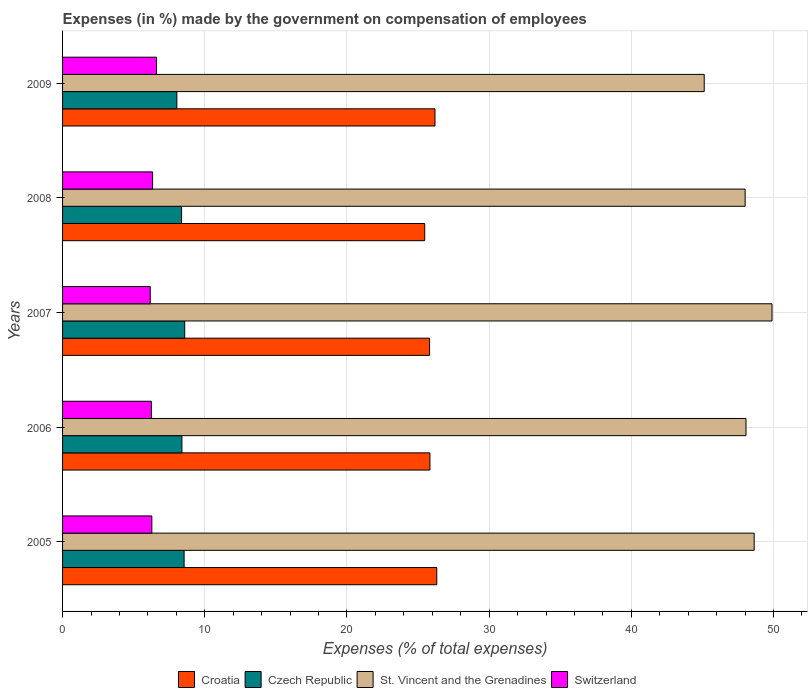How many different coloured bars are there?
Give a very brief answer. 4. Are the number of bars on each tick of the Y-axis equal?
Your answer should be compact. Yes. How many bars are there on the 2nd tick from the top?
Your answer should be very brief. 4. In how many cases, is the number of bars for a given year not equal to the number of legend labels?
Provide a succinct answer. 0. What is the percentage of expenses made by the government on compensation of employees in Croatia in 2006?
Your answer should be very brief. 25.84. Across all years, what is the maximum percentage of expenses made by the government on compensation of employees in Switzerland?
Make the answer very short. 6.61. Across all years, what is the minimum percentage of expenses made by the government on compensation of employees in Switzerland?
Your answer should be very brief. 6.17. In which year was the percentage of expenses made by the government on compensation of employees in Switzerland minimum?
Keep it short and to the point. 2007. What is the total percentage of expenses made by the government on compensation of employees in Switzerland in the graph?
Ensure brevity in your answer.  31.63. What is the difference between the percentage of expenses made by the government on compensation of employees in St. Vincent and the Grenadines in 2006 and that in 2009?
Provide a short and direct response. 2.94. What is the difference between the percentage of expenses made by the government on compensation of employees in Croatia in 2009 and the percentage of expenses made by the government on compensation of employees in Czech Republic in 2008?
Offer a very short reply. 17.82. What is the average percentage of expenses made by the government on compensation of employees in Croatia per year?
Offer a very short reply. 25.93. In the year 2006, what is the difference between the percentage of expenses made by the government on compensation of employees in Switzerland and percentage of expenses made by the government on compensation of employees in St. Vincent and the Grenadines?
Your answer should be compact. -41.82. In how many years, is the percentage of expenses made by the government on compensation of employees in Croatia greater than 22 %?
Make the answer very short. 5. What is the ratio of the percentage of expenses made by the government on compensation of employees in Czech Republic in 2006 to that in 2007?
Provide a short and direct response. 0.98. Is the percentage of expenses made by the government on compensation of employees in Switzerland in 2005 less than that in 2006?
Offer a very short reply. No. What is the difference between the highest and the second highest percentage of expenses made by the government on compensation of employees in Switzerland?
Keep it short and to the point. 0.28. What is the difference between the highest and the lowest percentage of expenses made by the government on compensation of employees in Croatia?
Ensure brevity in your answer.  0.85. Is the sum of the percentage of expenses made by the government on compensation of employees in St. Vincent and the Grenadines in 2008 and 2009 greater than the maximum percentage of expenses made by the government on compensation of employees in Czech Republic across all years?
Ensure brevity in your answer.  Yes. Is it the case that in every year, the sum of the percentage of expenses made by the government on compensation of employees in Czech Republic and percentage of expenses made by the government on compensation of employees in Switzerland is greater than the sum of percentage of expenses made by the government on compensation of employees in Croatia and percentage of expenses made by the government on compensation of employees in St. Vincent and the Grenadines?
Give a very brief answer. No. What does the 3rd bar from the top in 2007 represents?
Provide a short and direct response. Czech Republic. What does the 3rd bar from the bottom in 2009 represents?
Provide a succinct answer. St. Vincent and the Grenadines. How many bars are there?
Provide a succinct answer. 20. Are all the bars in the graph horizontal?
Your answer should be very brief. Yes. What is the difference between two consecutive major ticks on the X-axis?
Give a very brief answer. 10. Are the values on the major ticks of X-axis written in scientific E-notation?
Your answer should be very brief. No. Does the graph contain grids?
Ensure brevity in your answer.  Yes. Where does the legend appear in the graph?
Make the answer very short. Bottom center. How many legend labels are there?
Your answer should be compact. 4. What is the title of the graph?
Ensure brevity in your answer.  Expenses (in %) made by the government on compensation of employees. Does "Rwanda" appear as one of the legend labels in the graph?
Give a very brief answer. No. What is the label or title of the X-axis?
Offer a terse response. Expenses (% of total expenses). What is the Expenses (% of total expenses) in Croatia in 2005?
Your answer should be compact. 26.32. What is the Expenses (% of total expenses) of Czech Republic in 2005?
Ensure brevity in your answer.  8.55. What is the Expenses (% of total expenses) of St. Vincent and the Grenadines in 2005?
Provide a succinct answer. 48.64. What is the Expenses (% of total expenses) in Switzerland in 2005?
Ensure brevity in your answer.  6.28. What is the Expenses (% of total expenses) of Croatia in 2006?
Your answer should be very brief. 25.84. What is the Expenses (% of total expenses) in Czech Republic in 2006?
Offer a terse response. 8.39. What is the Expenses (% of total expenses) in St. Vincent and the Grenadines in 2006?
Give a very brief answer. 48.06. What is the Expenses (% of total expenses) of Switzerland in 2006?
Ensure brevity in your answer.  6.24. What is the Expenses (% of total expenses) of Croatia in 2007?
Give a very brief answer. 25.81. What is the Expenses (% of total expenses) in Czech Republic in 2007?
Provide a succinct answer. 8.59. What is the Expenses (% of total expenses) of St. Vincent and the Grenadines in 2007?
Provide a short and direct response. 49.89. What is the Expenses (% of total expenses) in Switzerland in 2007?
Your answer should be compact. 6.17. What is the Expenses (% of total expenses) of Croatia in 2008?
Offer a very short reply. 25.47. What is the Expenses (% of total expenses) in Czech Republic in 2008?
Give a very brief answer. 8.37. What is the Expenses (% of total expenses) of St. Vincent and the Grenadines in 2008?
Keep it short and to the point. 48. What is the Expenses (% of total expenses) in Switzerland in 2008?
Make the answer very short. 6.33. What is the Expenses (% of total expenses) in Croatia in 2009?
Give a very brief answer. 26.19. What is the Expenses (% of total expenses) of Czech Republic in 2009?
Offer a terse response. 8.04. What is the Expenses (% of total expenses) in St. Vincent and the Grenadines in 2009?
Ensure brevity in your answer.  45.13. What is the Expenses (% of total expenses) in Switzerland in 2009?
Provide a succinct answer. 6.61. Across all years, what is the maximum Expenses (% of total expenses) of Croatia?
Your answer should be compact. 26.32. Across all years, what is the maximum Expenses (% of total expenses) of Czech Republic?
Your answer should be compact. 8.59. Across all years, what is the maximum Expenses (% of total expenses) of St. Vincent and the Grenadines?
Give a very brief answer. 49.89. Across all years, what is the maximum Expenses (% of total expenses) in Switzerland?
Make the answer very short. 6.61. Across all years, what is the minimum Expenses (% of total expenses) of Croatia?
Offer a very short reply. 25.47. Across all years, what is the minimum Expenses (% of total expenses) in Czech Republic?
Offer a terse response. 8.04. Across all years, what is the minimum Expenses (% of total expenses) of St. Vincent and the Grenadines?
Your response must be concise. 45.13. Across all years, what is the minimum Expenses (% of total expenses) of Switzerland?
Your answer should be compact. 6.17. What is the total Expenses (% of total expenses) of Croatia in the graph?
Give a very brief answer. 129.63. What is the total Expenses (% of total expenses) of Czech Republic in the graph?
Your answer should be compact. 41.94. What is the total Expenses (% of total expenses) in St. Vincent and the Grenadines in the graph?
Your response must be concise. 239.73. What is the total Expenses (% of total expenses) in Switzerland in the graph?
Provide a succinct answer. 31.63. What is the difference between the Expenses (% of total expenses) of Croatia in 2005 and that in 2006?
Provide a short and direct response. 0.48. What is the difference between the Expenses (% of total expenses) in Czech Republic in 2005 and that in 2006?
Give a very brief answer. 0.15. What is the difference between the Expenses (% of total expenses) of St. Vincent and the Grenadines in 2005 and that in 2006?
Give a very brief answer. 0.58. What is the difference between the Expenses (% of total expenses) in Switzerland in 2005 and that in 2006?
Ensure brevity in your answer.  0.03. What is the difference between the Expenses (% of total expenses) of Croatia in 2005 and that in 2007?
Offer a very short reply. 0.51. What is the difference between the Expenses (% of total expenses) in Czech Republic in 2005 and that in 2007?
Offer a very short reply. -0.04. What is the difference between the Expenses (% of total expenses) of St. Vincent and the Grenadines in 2005 and that in 2007?
Offer a very short reply. -1.25. What is the difference between the Expenses (% of total expenses) of Switzerland in 2005 and that in 2007?
Make the answer very short. 0.11. What is the difference between the Expenses (% of total expenses) of Croatia in 2005 and that in 2008?
Your response must be concise. 0.85. What is the difference between the Expenses (% of total expenses) in Czech Republic in 2005 and that in 2008?
Ensure brevity in your answer.  0.18. What is the difference between the Expenses (% of total expenses) in St. Vincent and the Grenadines in 2005 and that in 2008?
Provide a short and direct response. 0.64. What is the difference between the Expenses (% of total expenses) in Switzerland in 2005 and that in 2008?
Offer a terse response. -0.05. What is the difference between the Expenses (% of total expenses) in Croatia in 2005 and that in 2009?
Your response must be concise. 0.13. What is the difference between the Expenses (% of total expenses) of Czech Republic in 2005 and that in 2009?
Keep it short and to the point. 0.51. What is the difference between the Expenses (% of total expenses) in St. Vincent and the Grenadines in 2005 and that in 2009?
Make the answer very short. 3.51. What is the difference between the Expenses (% of total expenses) of Switzerland in 2005 and that in 2009?
Offer a terse response. -0.33. What is the difference between the Expenses (% of total expenses) in Croatia in 2006 and that in 2007?
Keep it short and to the point. 0.02. What is the difference between the Expenses (% of total expenses) of Czech Republic in 2006 and that in 2007?
Offer a very short reply. -0.2. What is the difference between the Expenses (% of total expenses) of St. Vincent and the Grenadines in 2006 and that in 2007?
Provide a succinct answer. -1.83. What is the difference between the Expenses (% of total expenses) of Switzerland in 2006 and that in 2007?
Offer a terse response. 0.08. What is the difference between the Expenses (% of total expenses) in Croatia in 2006 and that in 2008?
Offer a terse response. 0.37. What is the difference between the Expenses (% of total expenses) of Czech Republic in 2006 and that in 2008?
Provide a succinct answer. 0.02. What is the difference between the Expenses (% of total expenses) in St. Vincent and the Grenadines in 2006 and that in 2008?
Your answer should be compact. 0.06. What is the difference between the Expenses (% of total expenses) of Switzerland in 2006 and that in 2008?
Offer a very short reply. -0.09. What is the difference between the Expenses (% of total expenses) of Croatia in 2006 and that in 2009?
Ensure brevity in your answer.  -0.36. What is the difference between the Expenses (% of total expenses) of Czech Republic in 2006 and that in 2009?
Provide a short and direct response. 0.36. What is the difference between the Expenses (% of total expenses) of St. Vincent and the Grenadines in 2006 and that in 2009?
Make the answer very short. 2.94. What is the difference between the Expenses (% of total expenses) in Switzerland in 2006 and that in 2009?
Offer a very short reply. -0.36. What is the difference between the Expenses (% of total expenses) in Croatia in 2007 and that in 2008?
Give a very brief answer. 0.34. What is the difference between the Expenses (% of total expenses) in Czech Republic in 2007 and that in 2008?
Your response must be concise. 0.22. What is the difference between the Expenses (% of total expenses) in St. Vincent and the Grenadines in 2007 and that in 2008?
Give a very brief answer. 1.89. What is the difference between the Expenses (% of total expenses) of Switzerland in 2007 and that in 2008?
Provide a short and direct response. -0.16. What is the difference between the Expenses (% of total expenses) of Croatia in 2007 and that in 2009?
Provide a succinct answer. -0.38. What is the difference between the Expenses (% of total expenses) of Czech Republic in 2007 and that in 2009?
Give a very brief answer. 0.55. What is the difference between the Expenses (% of total expenses) in St. Vincent and the Grenadines in 2007 and that in 2009?
Provide a succinct answer. 4.77. What is the difference between the Expenses (% of total expenses) in Switzerland in 2007 and that in 2009?
Offer a very short reply. -0.44. What is the difference between the Expenses (% of total expenses) of Croatia in 2008 and that in 2009?
Give a very brief answer. -0.72. What is the difference between the Expenses (% of total expenses) of Czech Republic in 2008 and that in 2009?
Your answer should be compact. 0.33. What is the difference between the Expenses (% of total expenses) of St. Vincent and the Grenadines in 2008 and that in 2009?
Give a very brief answer. 2.88. What is the difference between the Expenses (% of total expenses) of Switzerland in 2008 and that in 2009?
Ensure brevity in your answer.  -0.28. What is the difference between the Expenses (% of total expenses) in Croatia in 2005 and the Expenses (% of total expenses) in Czech Republic in 2006?
Keep it short and to the point. 17.92. What is the difference between the Expenses (% of total expenses) of Croatia in 2005 and the Expenses (% of total expenses) of St. Vincent and the Grenadines in 2006?
Provide a succinct answer. -21.75. What is the difference between the Expenses (% of total expenses) of Croatia in 2005 and the Expenses (% of total expenses) of Switzerland in 2006?
Your response must be concise. 20.07. What is the difference between the Expenses (% of total expenses) in Czech Republic in 2005 and the Expenses (% of total expenses) in St. Vincent and the Grenadines in 2006?
Make the answer very short. -39.52. What is the difference between the Expenses (% of total expenses) in Czech Republic in 2005 and the Expenses (% of total expenses) in Switzerland in 2006?
Keep it short and to the point. 2.3. What is the difference between the Expenses (% of total expenses) in St. Vincent and the Grenadines in 2005 and the Expenses (% of total expenses) in Switzerland in 2006?
Keep it short and to the point. 42.4. What is the difference between the Expenses (% of total expenses) in Croatia in 2005 and the Expenses (% of total expenses) in Czech Republic in 2007?
Your answer should be compact. 17.73. What is the difference between the Expenses (% of total expenses) of Croatia in 2005 and the Expenses (% of total expenses) of St. Vincent and the Grenadines in 2007?
Make the answer very short. -23.58. What is the difference between the Expenses (% of total expenses) in Croatia in 2005 and the Expenses (% of total expenses) in Switzerland in 2007?
Offer a terse response. 20.15. What is the difference between the Expenses (% of total expenses) in Czech Republic in 2005 and the Expenses (% of total expenses) in St. Vincent and the Grenadines in 2007?
Provide a succinct answer. -41.35. What is the difference between the Expenses (% of total expenses) in Czech Republic in 2005 and the Expenses (% of total expenses) in Switzerland in 2007?
Offer a very short reply. 2.38. What is the difference between the Expenses (% of total expenses) in St. Vincent and the Grenadines in 2005 and the Expenses (% of total expenses) in Switzerland in 2007?
Your answer should be compact. 42.47. What is the difference between the Expenses (% of total expenses) in Croatia in 2005 and the Expenses (% of total expenses) in Czech Republic in 2008?
Your answer should be compact. 17.95. What is the difference between the Expenses (% of total expenses) of Croatia in 2005 and the Expenses (% of total expenses) of St. Vincent and the Grenadines in 2008?
Provide a short and direct response. -21.69. What is the difference between the Expenses (% of total expenses) of Croatia in 2005 and the Expenses (% of total expenses) of Switzerland in 2008?
Provide a succinct answer. 19.99. What is the difference between the Expenses (% of total expenses) of Czech Republic in 2005 and the Expenses (% of total expenses) of St. Vincent and the Grenadines in 2008?
Your answer should be very brief. -39.46. What is the difference between the Expenses (% of total expenses) in Czech Republic in 2005 and the Expenses (% of total expenses) in Switzerland in 2008?
Give a very brief answer. 2.22. What is the difference between the Expenses (% of total expenses) of St. Vincent and the Grenadines in 2005 and the Expenses (% of total expenses) of Switzerland in 2008?
Offer a very short reply. 42.31. What is the difference between the Expenses (% of total expenses) in Croatia in 2005 and the Expenses (% of total expenses) in Czech Republic in 2009?
Offer a terse response. 18.28. What is the difference between the Expenses (% of total expenses) in Croatia in 2005 and the Expenses (% of total expenses) in St. Vincent and the Grenadines in 2009?
Keep it short and to the point. -18.81. What is the difference between the Expenses (% of total expenses) of Croatia in 2005 and the Expenses (% of total expenses) of Switzerland in 2009?
Provide a succinct answer. 19.71. What is the difference between the Expenses (% of total expenses) in Czech Republic in 2005 and the Expenses (% of total expenses) in St. Vincent and the Grenadines in 2009?
Give a very brief answer. -36.58. What is the difference between the Expenses (% of total expenses) in Czech Republic in 2005 and the Expenses (% of total expenses) in Switzerland in 2009?
Offer a terse response. 1.94. What is the difference between the Expenses (% of total expenses) of St. Vincent and the Grenadines in 2005 and the Expenses (% of total expenses) of Switzerland in 2009?
Your response must be concise. 42.03. What is the difference between the Expenses (% of total expenses) of Croatia in 2006 and the Expenses (% of total expenses) of Czech Republic in 2007?
Give a very brief answer. 17.25. What is the difference between the Expenses (% of total expenses) of Croatia in 2006 and the Expenses (% of total expenses) of St. Vincent and the Grenadines in 2007?
Ensure brevity in your answer.  -24.06. What is the difference between the Expenses (% of total expenses) in Croatia in 2006 and the Expenses (% of total expenses) in Switzerland in 2007?
Provide a short and direct response. 19.67. What is the difference between the Expenses (% of total expenses) in Czech Republic in 2006 and the Expenses (% of total expenses) in St. Vincent and the Grenadines in 2007?
Offer a terse response. -41.5. What is the difference between the Expenses (% of total expenses) of Czech Republic in 2006 and the Expenses (% of total expenses) of Switzerland in 2007?
Give a very brief answer. 2.23. What is the difference between the Expenses (% of total expenses) in St. Vincent and the Grenadines in 2006 and the Expenses (% of total expenses) in Switzerland in 2007?
Your response must be concise. 41.9. What is the difference between the Expenses (% of total expenses) in Croatia in 2006 and the Expenses (% of total expenses) in Czech Republic in 2008?
Keep it short and to the point. 17.47. What is the difference between the Expenses (% of total expenses) of Croatia in 2006 and the Expenses (% of total expenses) of St. Vincent and the Grenadines in 2008?
Keep it short and to the point. -22.17. What is the difference between the Expenses (% of total expenses) in Croatia in 2006 and the Expenses (% of total expenses) in Switzerland in 2008?
Your answer should be compact. 19.5. What is the difference between the Expenses (% of total expenses) in Czech Republic in 2006 and the Expenses (% of total expenses) in St. Vincent and the Grenadines in 2008?
Your response must be concise. -39.61. What is the difference between the Expenses (% of total expenses) of Czech Republic in 2006 and the Expenses (% of total expenses) of Switzerland in 2008?
Make the answer very short. 2.06. What is the difference between the Expenses (% of total expenses) of St. Vincent and the Grenadines in 2006 and the Expenses (% of total expenses) of Switzerland in 2008?
Give a very brief answer. 41.73. What is the difference between the Expenses (% of total expenses) in Croatia in 2006 and the Expenses (% of total expenses) in Czech Republic in 2009?
Offer a very short reply. 17.8. What is the difference between the Expenses (% of total expenses) in Croatia in 2006 and the Expenses (% of total expenses) in St. Vincent and the Grenadines in 2009?
Provide a short and direct response. -19.29. What is the difference between the Expenses (% of total expenses) in Croatia in 2006 and the Expenses (% of total expenses) in Switzerland in 2009?
Offer a very short reply. 19.23. What is the difference between the Expenses (% of total expenses) in Czech Republic in 2006 and the Expenses (% of total expenses) in St. Vincent and the Grenadines in 2009?
Make the answer very short. -36.73. What is the difference between the Expenses (% of total expenses) in Czech Republic in 2006 and the Expenses (% of total expenses) in Switzerland in 2009?
Your answer should be very brief. 1.78. What is the difference between the Expenses (% of total expenses) in St. Vincent and the Grenadines in 2006 and the Expenses (% of total expenses) in Switzerland in 2009?
Offer a terse response. 41.45. What is the difference between the Expenses (% of total expenses) of Croatia in 2007 and the Expenses (% of total expenses) of Czech Republic in 2008?
Provide a succinct answer. 17.44. What is the difference between the Expenses (% of total expenses) in Croatia in 2007 and the Expenses (% of total expenses) in St. Vincent and the Grenadines in 2008?
Keep it short and to the point. -22.19. What is the difference between the Expenses (% of total expenses) of Croatia in 2007 and the Expenses (% of total expenses) of Switzerland in 2008?
Your answer should be compact. 19.48. What is the difference between the Expenses (% of total expenses) of Czech Republic in 2007 and the Expenses (% of total expenses) of St. Vincent and the Grenadines in 2008?
Provide a short and direct response. -39.41. What is the difference between the Expenses (% of total expenses) in Czech Republic in 2007 and the Expenses (% of total expenses) in Switzerland in 2008?
Offer a terse response. 2.26. What is the difference between the Expenses (% of total expenses) of St. Vincent and the Grenadines in 2007 and the Expenses (% of total expenses) of Switzerland in 2008?
Your response must be concise. 43.56. What is the difference between the Expenses (% of total expenses) in Croatia in 2007 and the Expenses (% of total expenses) in Czech Republic in 2009?
Provide a succinct answer. 17.77. What is the difference between the Expenses (% of total expenses) of Croatia in 2007 and the Expenses (% of total expenses) of St. Vincent and the Grenadines in 2009?
Provide a succinct answer. -19.31. What is the difference between the Expenses (% of total expenses) of Croatia in 2007 and the Expenses (% of total expenses) of Switzerland in 2009?
Make the answer very short. 19.2. What is the difference between the Expenses (% of total expenses) in Czech Republic in 2007 and the Expenses (% of total expenses) in St. Vincent and the Grenadines in 2009?
Make the answer very short. -36.54. What is the difference between the Expenses (% of total expenses) in Czech Republic in 2007 and the Expenses (% of total expenses) in Switzerland in 2009?
Keep it short and to the point. 1.98. What is the difference between the Expenses (% of total expenses) of St. Vincent and the Grenadines in 2007 and the Expenses (% of total expenses) of Switzerland in 2009?
Your answer should be compact. 43.28. What is the difference between the Expenses (% of total expenses) of Croatia in 2008 and the Expenses (% of total expenses) of Czech Republic in 2009?
Provide a short and direct response. 17.43. What is the difference between the Expenses (% of total expenses) of Croatia in 2008 and the Expenses (% of total expenses) of St. Vincent and the Grenadines in 2009?
Offer a terse response. -19.66. What is the difference between the Expenses (% of total expenses) of Croatia in 2008 and the Expenses (% of total expenses) of Switzerland in 2009?
Ensure brevity in your answer.  18.86. What is the difference between the Expenses (% of total expenses) of Czech Republic in 2008 and the Expenses (% of total expenses) of St. Vincent and the Grenadines in 2009?
Keep it short and to the point. -36.76. What is the difference between the Expenses (% of total expenses) of Czech Republic in 2008 and the Expenses (% of total expenses) of Switzerland in 2009?
Provide a succinct answer. 1.76. What is the difference between the Expenses (% of total expenses) of St. Vincent and the Grenadines in 2008 and the Expenses (% of total expenses) of Switzerland in 2009?
Give a very brief answer. 41.39. What is the average Expenses (% of total expenses) of Croatia per year?
Your answer should be compact. 25.93. What is the average Expenses (% of total expenses) of Czech Republic per year?
Ensure brevity in your answer.  8.39. What is the average Expenses (% of total expenses) in St. Vincent and the Grenadines per year?
Give a very brief answer. 47.95. What is the average Expenses (% of total expenses) of Switzerland per year?
Make the answer very short. 6.33. In the year 2005, what is the difference between the Expenses (% of total expenses) of Croatia and Expenses (% of total expenses) of Czech Republic?
Offer a very short reply. 17.77. In the year 2005, what is the difference between the Expenses (% of total expenses) of Croatia and Expenses (% of total expenses) of St. Vincent and the Grenadines?
Make the answer very short. -22.32. In the year 2005, what is the difference between the Expenses (% of total expenses) in Croatia and Expenses (% of total expenses) in Switzerland?
Ensure brevity in your answer.  20.04. In the year 2005, what is the difference between the Expenses (% of total expenses) of Czech Republic and Expenses (% of total expenses) of St. Vincent and the Grenadines?
Ensure brevity in your answer.  -40.09. In the year 2005, what is the difference between the Expenses (% of total expenses) of Czech Republic and Expenses (% of total expenses) of Switzerland?
Your response must be concise. 2.27. In the year 2005, what is the difference between the Expenses (% of total expenses) of St. Vincent and the Grenadines and Expenses (% of total expenses) of Switzerland?
Offer a very short reply. 42.36. In the year 2006, what is the difference between the Expenses (% of total expenses) in Croatia and Expenses (% of total expenses) in Czech Republic?
Your response must be concise. 17.44. In the year 2006, what is the difference between the Expenses (% of total expenses) in Croatia and Expenses (% of total expenses) in St. Vincent and the Grenadines?
Provide a succinct answer. -22.23. In the year 2006, what is the difference between the Expenses (% of total expenses) of Croatia and Expenses (% of total expenses) of Switzerland?
Your answer should be compact. 19.59. In the year 2006, what is the difference between the Expenses (% of total expenses) of Czech Republic and Expenses (% of total expenses) of St. Vincent and the Grenadines?
Offer a terse response. -39.67. In the year 2006, what is the difference between the Expenses (% of total expenses) in Czech Republic and Expenses (% of total expenses) in Switzerland?
Your answer should be compact. 2.15. In the year 2006, what is the difference between the Expenses (% of total expenses) of St. Vincent and the Grenadines and Expenses (% of total expenses) of Switzerland?
Give a very brief answer. 41.82. In the year 2007, what is the difference between the Expenses (% of total expenses) of Croatia and Expenses (% of total expenses) of Czech Republic?
Offer a very short reply. 17.22. In the year 2007, what is the difference between the Expenses (% of total expenses) of Croatia and Expenses (% of total expenses) of St. Vincent and the Grenadines?
Provide a succinct answer. -24.08. In the year 2007, what is the difference between the Expenses (% of total expenses) in Croatia and Expenses (% of total expenses) in Switzerland?
Make the answer very short. 19.65. In the year 2007, what is the difference between the Expenses (% of total expenses) in Czech Republic and Expenses (% of total expenses) in St. Vincent and the Grenadines?
Your response must be concise. -41.3. In the year 2007, what is the difference between the Expenses (% of total expenses) in Czech Republic and Expenses (% of total expenses) in Switzerland?
Ensure brevity in your answer.  2.42. In the year 2007, what is the difference between the Expenses (% of total expenses) in St. Vincent and the Grenadines and Expenses (% of total expenses) in Switzerland?
Your answer should be compact. 43.73. In the year 2008, what is the difference between the Expenses (% of total expenses) of Croatia and Expenses (% of total expenses) of Czech Republic?
Your answer should be compact. 17.1. In the year 2008, what is the difference between the Expenses (% of total expenses) in Croatia and Expenses (% of total expenses) in St. Vincent and the Grenadines?
Your answer should be compact. -22.53. In the year 2008, what is the difference between the Expenses (% of total expenses) of Croatia and Expenses (% of total expenses) of Switzerland?
Provide a succinct answer. 19.14. In the year 2008, what is the difference between the Expenses (% of total expenses) in Czech Republic and Expenses (% of total expenses) in St. Vincent and the Grenadines?
Offer a very short reply. -39.63. In the year 2008, what is the difference between the Expenses (% of total expenses) of Czech Republic and Expenses (% of total expenses) of Switzerland?
Provide a succinct answer. 2.04. In the year 2008, what is the difference between the Expenses (% of total expenses) in St. Vincent and the Grenadines and Expenses (% of total expenses) in Switzerland?
Your response must be concise. 41.67. In the year 2009, what is the difference between the Expenses (% of total expenses) in Croatia and Expenses (% of total expenses) in Czech Republic?
Your answer should be very brief. 18.15. In the year 2009, what is the difference between the Expenses (% of total expenses) of Croatia and Expenses (% of total expenses) of St. Vincent and the Grenadines?
Your answer should be very brief. -18.93. In the year 2009, what is the difference between the Expenses (% of total expenses) of Croatia and Expenses (% of total expenses) of Switzerland?
Offer a very short reply. 19.58. In the year 2009, what is the difference between the Expenses (% of total expenses) of Czech Republic and Expenses (% of total expenses) of St. Vincent and the Grenadines?
Ensure brevity in your answer.  -37.09. In the year 2009, what is the difference between the Expenses (% of total expenses) in Czech Republic and Expenses (% of total expenses) in Switzerland?
Give a very brief answer. 1.43. In the year 2009, what is the difference between the Expenses (% of total expenses) of St. Vincent and the Grenadines and Expenses (% of total expenses) of Switzerland?
Make the answer very short. 38.52. What is the ratio of the Expenses (% of total expenses) in Croatia in 2005 to that in 2006?
Provide a succinct answer. 1.02. What is the ratio of the Expenses (% of total expenses) in Czech Republic in 2005 to that in 2006?
Ensure brevity in your answer.  1.02. What is the ratio of the Expenses (% of total expenses) in St. Vincent and the Grenadines in 2005 to that in 2006?
Keep it short and to the point. 1.01. What is the ratio of the Expenses (% of total expenses) in Switzerland in 2005 to that in 2006?
Make the answer very short. 1.01. What is the ratio of the Expenses (% of total expenses) in Croatia in 2005 to that in 2007?
Your answer should be very brief. 1.02. What is the ratio of the Expenses (% of total expenses) of Czech Republic in 2005 to that in 2007?
Provide a succinct answer. 1. What is the ratio of the Expenses (% of total expenses) of St. Vincent and the Grenadines in 2005 to that in 2007?
Your response must be concise. 0.97. What is the ratio of the Expenses (% of total expenses) in Switzerland in 2005 to that in 2007?
Offer a very short reply. 1.02. What is the ratio of the Expenses (% of total expenses) of Czech Republic in 2005 to that in 2008?
Provide a succinct answer. 1.02. What is the ratio of the Expenses (% of total expenses) in St. Vincent and the Grenadines in 2005 to that in 2008?
Give a very brief answer. 1.01. What is the ratio of the Expenses (% of total expenses) of Czech Republic in 2005 to that in 2009?
Your answer should be very brief. 1.06. What is the ratio of the Expenses (% of total expenses) in St. Vincent and the Grenadines in 2005 to that in 2009?
Provide a short and direct response. 1.08. What is the ratio of the Expenses (% of total expenses) in Switzerland in 2005 to that in 2009?
Offer a terse response. 0.95. What is the ratio of the Expenses (% of total expenses) in Czech Republic in 2006 to that in 2007?
Provide a succinct answer. 0.98. What is the ratio of the Expenses (% of total expenses) in St. Vincent and the Grenadines in 2006 to that in 2007?
Offer a terse response. 0.96. What is the ratio of the Expenses (% of total expenses) of Switzerland in 2006 to that in 2007?
Make the answer very short. 1.01. What is the ratio of the Expenses (% of total expenses) in Croatia in 2006 to that in 2008?
Provide a short and direct response. 1.01. What is the ratio of the Expenses (% of total expenses) of St. Vincent and the Grenadines in 2006 to that in 2008?
Give a very brief answer. 1. What is the ratio of the Expenses (% of total expenses) of Switzerland in 2006 to that in 2008?
Your answer should be compact. 0.99. What is the ratio of the Expenses (% of total expenses) in Croatia in 2006 to that in 2009?
Offer a very short reply. 0.99. What is the ratio of the Expenses (% of total expenses) in Czech Republic in 2006 to that in 2009?
Keep it short and to the point. 1.04. What is the ratio of the Expenses (% of total expenses) in St. Vincent and the Grenadines in 2006 to that in 2009?
Offer a terse response. 1.07. What is the ratio of the Expenses (% of total expenses) of Switzerland in 2006 to that in 2009?
Provide a short and direct response. 0.94. What is the ratio of the Expenses (% of total expenses) in Croatia in 2007 to that in 2008?
Give a very brief answer. 1.01. What is the ratio of the Expenses (% of total expenses) in Czech Republic in 2007 to that in 2008?
Give a very brief answer. 1.03. What is the ratio of the Expenses (% of total expenses) in St. Vincent and the Grenadines in 2007 to that in 2008?
Your answer should be compact. 1.04. What is the ratio of the Expenses (% of total expenses) of Switzerland in 2007 to that in 2008?
Your response must be concise. 0.97. What is the ratio of the Expenses (% of total expenses) in Croatia in 2007 to that in 2009?
Your answer should be compact. 0.99. What is the ratio of the Expenses (% of total expenses) of Czech Republic in 2007 to that in 2009?
Your answer should be very brief. 1.07. What is the ratio of the Expenses (% of total expenses) of St. Vincent and the Grenadines in 2007 to that in 2009?
Your response must be concise. 1.11. What is the ratio of the Expenses (% of total expenses) of Switzerland in 2007 to that in 2009?
Keep it short and to the point. 0.93. What is the ratio of the Expenses (% of total expenses) in Croatia in 2008 to that in 2009?
Your response must be concise. 0.97. What is the ratio of the Expenses (% of total expenses) in Czech Republic in 2008 to that in 2009?
Give a very brief answer. 1.04. What is the ratio of the Expenses (% of total expenses) in St. Vincent and the Grenadines in 2008 to that in 2009?
Give a very brief answer. 1.06. What is the ratio of the Expenses (% of total expenses) of Switzerland in 2008 to that in 2009?
Offer a terse response. 0.96. What is the difference between the highest and the second highest Expenses (% of total expenses) in Croatia?
Offer a terse response. 0.13. What is the difference between the highest and the second highest Expenses (% of total expenses) in Czech Republic?
Give a very brief answer. 0.04. What is the difference between the highest and the second highest Expenses (% of total expenses) of St. Vincent and the Grenadines?
Offer a terse response. 1.25. What is the difference between the highest and the second highest Expenses (% of total expenses) of Switzerland?
Make the answer very short. 0.28. What is the difference between the highest and the lowest Expenses (% of total expenses) in Croatia?
Your response must be concise. 0.85. What is the difference between the highest and the lowest Expenses (% of total expenses) in Czech Republic?
Offer a very short reply. 0.55. What is the difference between the highest and the lowest Expenses (% of total expenses) in St. Vincent and the Grenadines?
Ensure brevity in your answer.  4.77. What is the difference between the highest and the lowest Expenses (% of total expenses) of Switzerland?
Provide a short and direct response. 0.44. 